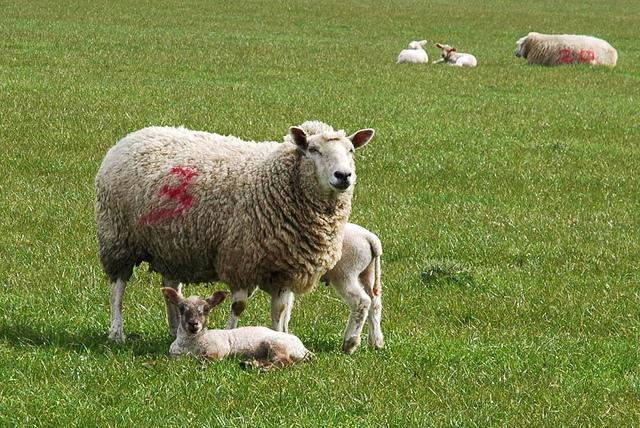What material do these animals provide for clothing?

Choices:
A) silk
B) wool
C) polyester
D) cotton wool 